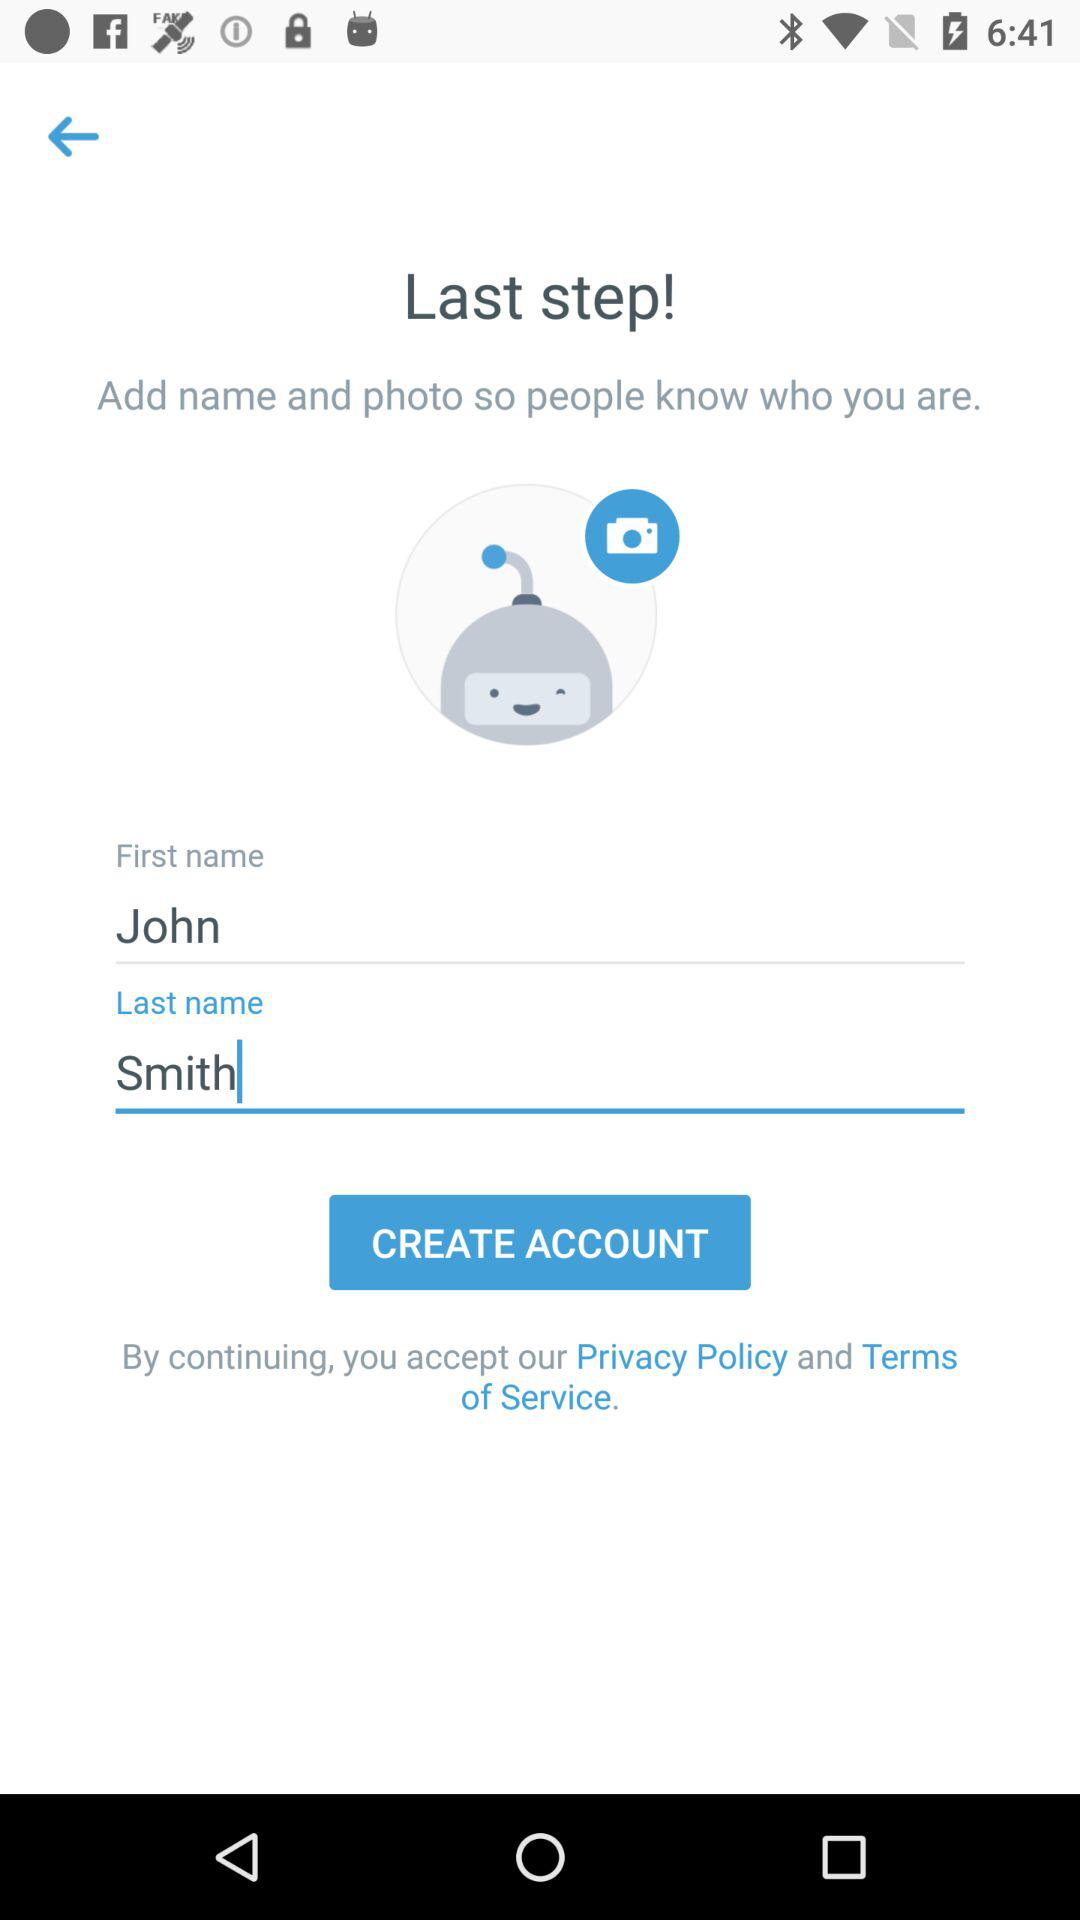At what step am I at? You are at the last step. 